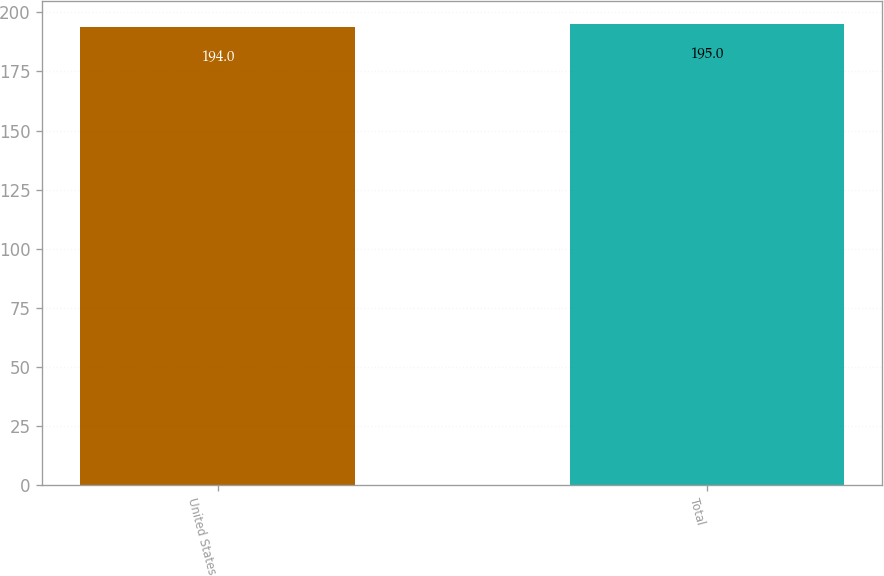Convert chart. <chart><loc_0><loc_0><loc_500><loc_500><bar_chart><fcel>United States<fcel>Total<nl><fcel>194<fcel>195<nl></chart> 